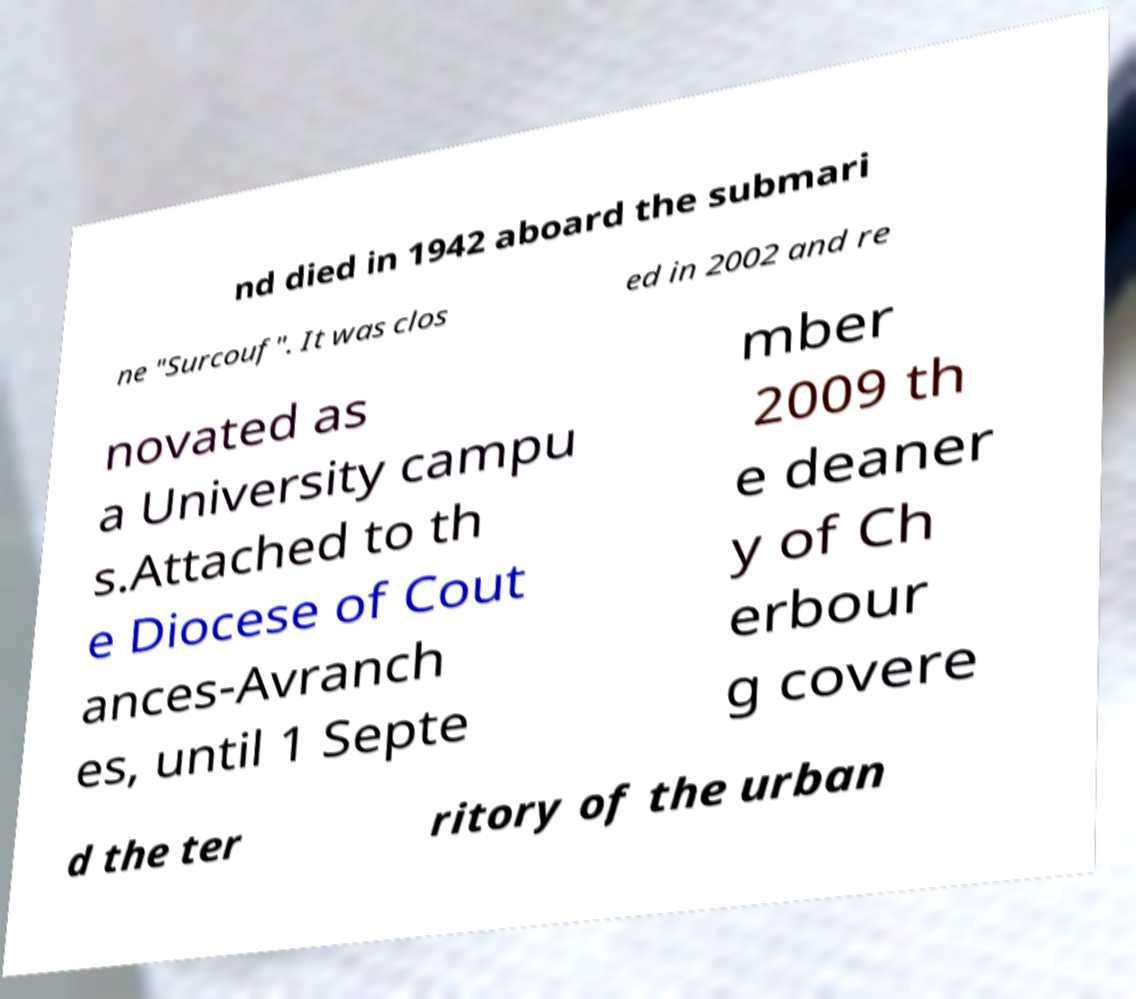There's text embedded in this image that I need extracted. Can you transcribe it verbatim? nd died in 1942 aboard the submari ne "Surcouf". It was clos ed in 2002 and re novated as a University campu s.Attached to th e Diocese of Cout ances-Avranch es, until 1 Septe mber 2009 th e deaner y of Ch erbour g covere d the ter ritory of the urban 